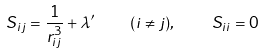<formula> <loc_0><loc_0><loc_500><loc_500>S _ { i j } = \frac { 1 } { r _ { i j } ^ { 3 } } + \lambda ^ { \prime } \quad ( i \neq j ) , \quad S _ { i i } = 0</formula> 